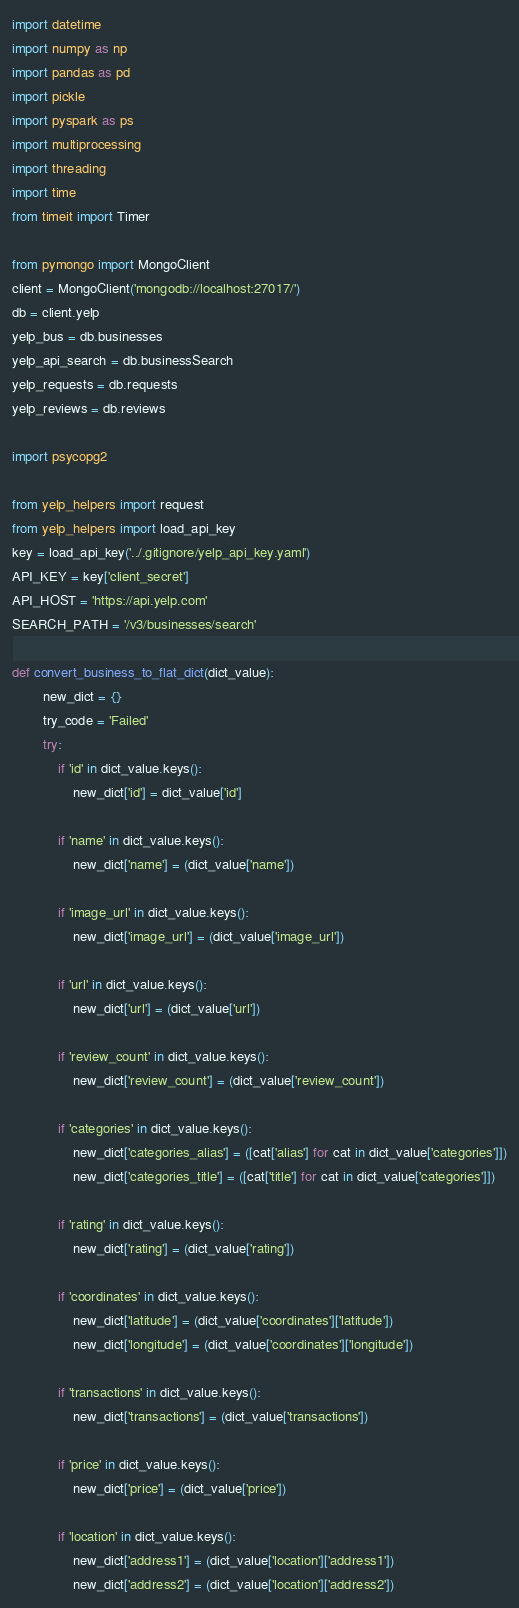<code> <loc_0><loc_0><loc_500><loc_500><_Python_>import datetime
import numpy as np
import pandas as pd
import pickle
import pyspark as ps
import multiprocessing
import threading
import time
from timeit import Timer

from pymongo import MongoClient
client = MongoClient('mongodb://localhost:27017/')
db = client.yelp
yelp_bus = db.businesses
yelp_api_search = db.businessSearch
yelp_requests = db.requests
yelp_reviews = db.reviews

import psycopg2

from yelp_helpers import request
from yelp_helpers import load_api_key
key = load_api_key('../.gitignore/yelp_api_key.yaml')
API_KEY = key['client_secret']
API_HOST = 'https://api.yelp.com'
SEARCH_PATH = '/v3/businesses/search'

def convert_business_to_flat_dict(dict_value):
        new_dict = {}
        try_code = 'Failed'
        try:
            if 'id' in dict_value.keys():
                new_dict['id'] = dict_value['id']
            
            if 'name' in dict_value.keys():
                new_dict['name'] = (dict_value['name'])
            
            if 'image_url' in dict_value.keys():
                new_dict['image_url'] = (dict_value['image_url'])
            
            if 'url' in dict_value.keys():
                new_dict['url'] = (dict_value['url'])
            
            if 'review_count' in dict_value.keys():
                new_dict['review_count'] = (dict_value['review_count'])
            
            if 'categories' in dict_value.keys():
                new_dict['categories_alias'] = ([cat['alias'] for cat in dict_value['categories']])
                new_dict['categories_title'] = ([cat['title'] for cat in dict_value['categories']])
            
            if 'rating' in dict_value.keys():
                new_dict['rating'] = (dict_value['rating'])
            
            if 'coordinates' in dict_value.keys():
                new_dict['latitude'] = (dict_value['coordinates']['latitude'])
                new_dict['longitude'] = (dict_value['coordinates']['longitude'])
            
            if 'transactions' in dict_value.keys():
                new_dict['transactions'] = (dict_value['transactions'])
            
            if 'price' in dict_value.keys():
                new_dict['price'] = (dict_value['price'])
                
            if 'location' in dict_value.keys():
                new_dict['address1'] = (dict_value['location']['address1'])
                new_dict['address2'] = (dict_value['location']['address2'])</code> 